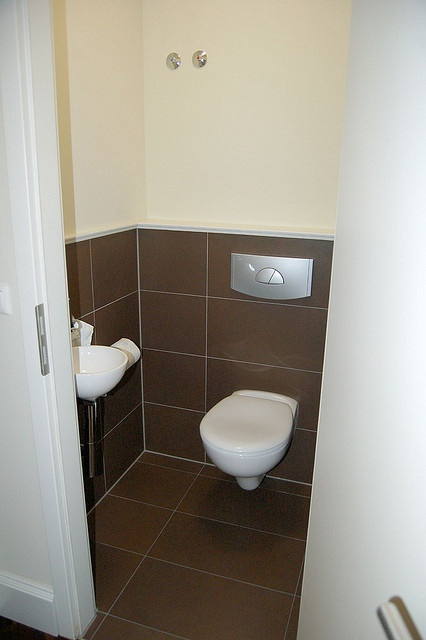Describe the objects in this image and their specific colors. I can see toilet in gray, darkgray, lightgray, and black tones and sink in gray, lightgray, and darkgray tones in this image. 